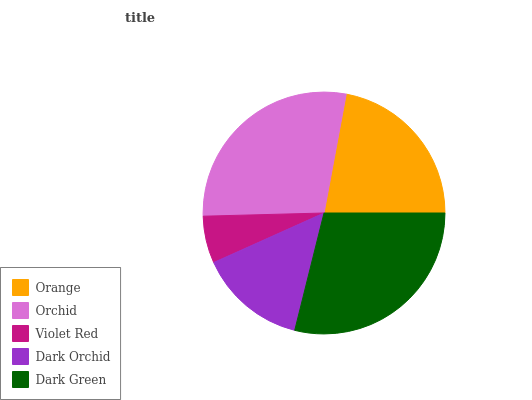Is Violet Red the minimum?
Answer yes or no. Yes. Is Dark Green the maximum?
Answer yes or no. Yes. Is Orchid the minimum?
Answer yes or no. No. Is Orchid the maximum?
Answer yes or no. No. Is Orchid greater than Orange?
Answer yes or no. Yes. Is Orange less than Orchid?
Answer yes or no. Yes. Is Orange greater than Orchid?
Answer yes or no. No. Is Orchid less than Orange?
Answer yes or no. No. Is Orange the high median?
Answer yes or no. Yes. Is Orange the low median?
Answer yes or no. Yes. Is Orchid the high median?
Answer yes or no. No. Is Dark Green the low median?
Answer yes or no. No. 